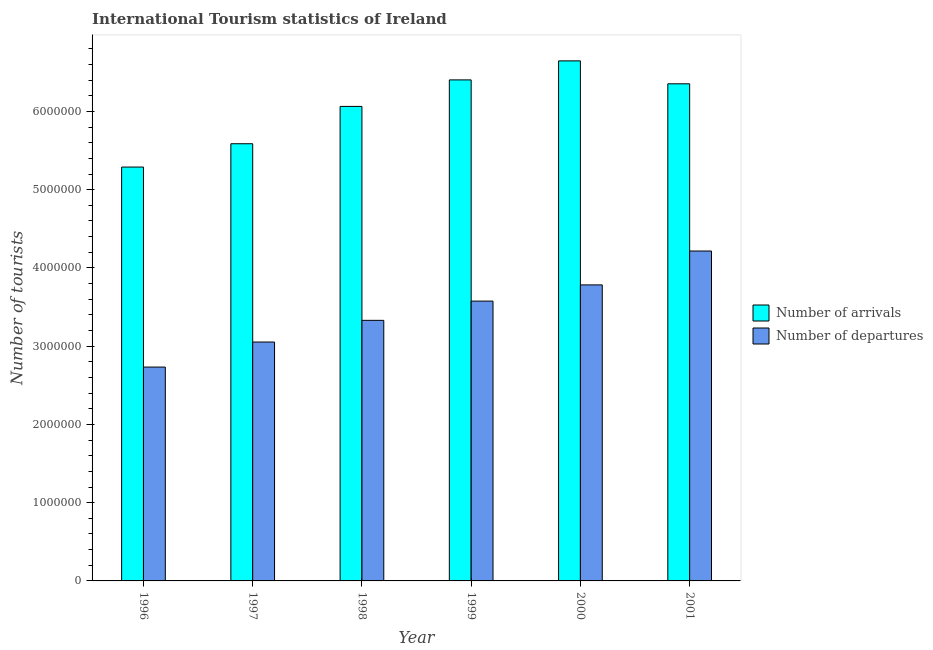How many different coloured bars are there?
Make the answer very short. 2. Are the number of bars per tick equal to the number of legend labels?
Provide a succinct answer. Yes. How many bars are there on the 1st tick from the right?
Provide a succinct answer. 2. What is the label of the 1st group of bars from the left?
Give a very brief answer. 1996. What is the number of tourist departures in 2001?
Your response must be concise. 4.22e+06. Across all years, what is the maximum number of tourist departures?
Provide a succinct answer. 4.22e+06. Across all years, what is the minimum number of tourist departures?
Offer a terse response. 2.73e+06. In which year was the number of tourist arrivals maximum?
Provide a succinct answer. 2000. What is the total number of tourist departures in the graph?
Offer a terse response. 2.07e+07. What is the difference between the number of tourist arrivals in 1997 and that in 2000?
Make the answer very short. -1.06e+06. What is the difference between the number of tourist departures in 1999 and the number of tourist arrivals in 1998?
Give a very brief answer. 2.46e+05. What is the average number of tourist departures per year?
Your answer should be very brief. 3.45e+06. In how many years, is the number of tourist departures greater than 5800000?
Give a very brief answer. 0. What is the ratio of the number of tourist departures in 1998 to that in 2001?
Provide a succinct answer. 0.79. Is the number of tourist arrivals in 2000 less than that in 2001?
Your answer should be very brief. No. What is the difference between the highest and the second highest number of tourist departures?
Give a very brief answer. 4.33e+05. What is the difference between the highest and the lowest number of tourist departures?
Provide a short and direct response. 1.48e+06. In how many years, is the number of tourist departures greater than the average number of tourist departures taken over all years?
Ensure brevity in your answer.  3. What does the 1st bar from the left in 1999 represents?
Keep it short and to the point. Number of arrivals. What does the 1st bar from the right in 1997 represents?
Provide a succinct answer. Number of departures. Are all the bars in the graph horizontal?
Ensure brevity in your answer.  No. Are the values on the major ticks of Y-axis written in scientific E-notation?
Keep it short and to the point. No. Does the graph contain grids?
Give a very brief answer. No. Where does the legend appear in the graph?
Your response must be concise. Center right. How many legend labels are there?
Offer a very short reply. 2. What is the title of the graph?
Your response must be concise. International Tourism statistics of Ireland. Does "Male population" appear as one of the legend labels in the graph?
Offer a very short reply. No. What is the label or title of the Y-axis?
Provide a short and direct response. Number of tourists. What is the Number of tourists in Number of arrivals in 1996?
Give a very brief answer. 5.29e+06. What is the Number of tourists in Number of departures in 1996?
Your response must be concise. 2.73e+06. What is the Number of tourists of Number of arrivals in 1997?
Provide a short and direct response. 5.59e+06. What is the Number of tourists in Number of departures in 1997?
Offer a terse response. 3.05e+06. What is the Number of tourists of Number of arrivals in 1998?
Your response must be concise. 6.06e+06. What is the Number of tourists of Number of departures in 1998?
Offer a very short reply. 3.33e+06. What is the Number of tourists of Number of arrivals in 1999?
Your answer should be very brief. 6.40e+06. What is the Number of tourists in Number of departures in 1999?
Offer a terse response. 3.58e+06. What is the Number of tourists of Number of arrivals in 2000?
Offer a terse response. 6.65e+06. What is the Number of tourists in Number of departures in 2000?
Give a very brief answer. 3.78e+06. What is the Number of tourists in Number of arrivals in 2001?
Make the answer very short. 6.35e+06. What is the Number of tourists in Number of departures in 2001?
Provide a succinct answer. 4.22e+06. Across all years, what is the maximum Number of tourists of Number of arrivals?
Your answer should be very brief. 6.65e+06. Across all years, what is the maximum Number of tourists in Number of departures?
Your response must be concise. 4.22e+06. Across all years, what is the minimum Number of tourists of Number of arrivals?
Your response must be concise. 5.29e+06. Across all years, what is the minimum Number of tourists in Number of departures?
Provide a succinct answer. 2.73e+06. What is the total Number of tourists in Number of arrivals in the graph?
Keep it short and to the point. 3.63e+07. What is the total Number of tourists in Number of departures in the graph?
Give a very brief answer. 2.07e+07. What is the difference between the Number of tourists in Number of arrivals in 1996 and that in 1997?
Your answer should be compact. -2.98e+05. What is the difference between the Number of tourists in Number of departures in 1996 and that in 1997?
Provide a short and direct response. -3.20e+05. What is the difference between the Number of tourists in Number of arrivals in 1996 and that in 1998?
Keep it short and to the point. -7.75e+05. What is the difference between the Number of tourists in Number of departures in 1996 and that in 1998?
Your answer should be very brief. -5.97e+05. What is the difference between the Number of tourists of Number of arrivals in 1996 and that in 1999?
Offer a very short reply. -1.11e+06. What is the difference between the Number of tourists in Number of departures in 1996 and that in 1999?
Give a very brief answer. -8.43e+05. What is the difference between the Number of tourists of Number of arrivals in 1996 and that in 2000?
Your response must be concise. -1.36e+06. What is the difference between the Number of tourists of Number of departures in 1996 and that in 2000?
Offer a terse response. -1.05e+06. What is the difference between the Number of tourists of Number of arrivals in 1996 and that in 2001?
Make the answer very short. -1.06e+06. What is the difference between the Number of tourists of Number of departures in 1996 and that in 2001?
Provide a short and direct response. -1.48e+06. What is the difference between the Number of tourists in Number of arrivals in 1997 and that in 1998?
Give a very brief answer. -4.77e+05. What is the difference between the Number of tourists in Number of departures in 1997 and that in 1998?
Give a very brief answer. -2.77e+05. What is the difference between the Number of tourists of Number of arrivals in 1997 and that in 1999?
Make the answer very short. -8.16e+05. What is the difference between the Number of tourists in Number of departures in 1997 and that in 1999?
Your response must be concise. -5.23e+05. What is the difference between the Number of tourists of Number of arrivals in 1997 and that in 2000?
Ensure brevity in your answer.  -1.06e+06. What is the difference between the Number of tourists in Number of departures in 1997 and that in 2000?
Provide a succinct answer. -7.30e+05. What is the difference between the Number of tourists in Number of arrivals in 1997 and that in 2001?
Offer a terse response. -7.66e+05. What is the difference between the Number of tourists of Number of departures in 1997 and that in 2001?
Your answer should be compact. -1.16e+06. What is the difference between the Number of tourists in Number of arrivals in 1998 and that in 1999?
Your answer should be very brief. -3.39e+05. What is the difference between the Number of tourists in Number of departures in 1998 and that in 1999?
Provide a succinct answer. -2.46e+05. What is the difference between the Number of tourists of Number of arrivals in 1998 and that in 2000?
Provide a succinct answer. -5.82e+05. What is the difference between the Number of tourists of Number of departures in 1998 and that in 2000?
Offer a terse response. -4.53e+05. What is the difference between the Number of tourists of Number of arrivals in 1998 and that in 2001?
Offer a terse response. -2.89e+05. What is the difference between the Number of tourists in Number of departures in 1998 and that in 2001?
Make the answer very short. -8.86e+05. What is the difference between the Number of tourists of Number of arrivals in 1999 and that in 2000?
Provide a short and direct response. -2.43e+05. What is the difference between the Number of tourists in Number of departures in 1999 and that in 2000?
Offer a very short reply. -2.07e+05. What is the difference between the Number of tourists in Number of arrivals in 1999 and that in 2001?
Provide a succinct answer. 5.00e+04. What is the difference between the Number of tourists in Number of departures in 1999 and that in 2001?
Ensure brevity in your answer.  -6.40e+05. What is the difference between the Number of tourists in Number of arrivals in 2000 and that in 2001?
Your answer should be very brief. 2.93e+05. What is the difference between the Number of tourists in Number of departures in 2000 and that in 2001?
Give a very brief answer. -4.33e+05. What is the difference between the Number of tourists of Number of arrivals in 1996 and the Number of tourists of Number of departures in 1997?
Your answer should be compact. 2.24e+06. What is the difference between the Number of tourists in Number of arrivals in 1996 and the Number of tourists in Number of departures in 1998?
Your answer should be compact. 1.96e+06. What is the difference between the Number of tourists of Number of arrivals in 1996 and the Number of tourists of Number of departures in 1999?
Your answer should be very brief. 1.71e+06. What is the difference between the Number of tourists in Number of arrivals in 1996 and the Number of tourists in Number of departures in 2000?
Ensure brevity in your answer.  1.51e+06. What is the difference between the Number of tourists of Number of arrivals in 1996 and the Number of tourists of Number of departures in 2001?
Ensure brevity in your answer.  1.07e+06. What is the difference between the Number of tourists in Number of arrivals in 1997 and the Number of tourists in Number of departures in 1998?
Offer a very short reply. 2.26e+06. What is the difference between the Number of tourists of Number of arrivals in 1997 and the Number of tourists of Number of departures in 1999?
Provide a short and direct response. 2.01e+06. What is the difference between the Number of tourists of Number of arrivals in 1997 and the Number of tourists of Number of departures in 2000?
Provide a succinct answer. 1.80e+06. What is the difference between the Number of tourists in Number of arrivals in 1997 and the Number of tourists in Number of departures in 2001?
Provide a short and direct response. 1.37e+06. What is the difference between the Number of tourists of Number of arrivals in 1998 and the Number of tourists of Number of departures in 1999?
Ensure brevity in your answer.  2.49e+06. What is the difference between the Number of tourists in Number of arrivals in 1998 and the Number of tourists in Number of departures in 2000?
Offer a very short reply. 2.28e+06. What is the difference between the Number of tourists in Number of arrivals in 1998 and the Number of tourists in Number of departures in 2001?
Your response must be concise. 1.85e+06. What is the difference between the Number of tourists in Number of arrivals in 1999 and the Number of tourists in Number of departures in 2000?
Give a very brief answer. 2.62e+06. What is the difference between the Number of tourists in Number of arrivals in 1999 and the Number of tourists in Number of departures in 2001?
Give a very brief answer. 2.19e+06. What is the difference between the Number of tourists of Number of arrivals in 2000 and the Number of tourists of Number of departures in 2001?
Give a very brief answer. 2.43e+06. What is the average Number of tourists of Number of arrivals per year?
Provide a short and direct response. 6.06e+06. What is the average Number of tourists of Number of departures per year?
Your answer should be very brief. 3.45e+06. In the year 1996, what is the difference between the Number of tourists in Number of arrivals and Number of tourists in Number of departures?
Your answer should be compact. 2.56e+06. In the year 1997, what is the difference between the Number of tourists in Number of arrivals and Number of tourists in Number of departures?
Provide a succinct answer. 2.53e+06. In the year 1998, what is the difference between the Number of tourists of Number of arrivals and Number of tourists of Number of departures?
Keep it short and to the point. 2.73e+06. In the year 1999, what is the difference between the Number of tourists of Number of arrivals and Number of tourists of Number of departures?
Ensure brevity in your answer.  2.83e+06. In the year 2000, what is the difference between the Number of tourists in Number of arrivals and Number of tourists in Number of departures?
Give a very brief answer. 2.86e+06. In the year 2001, what is the difference between the Number of tourists in Number of arrivals and Number of tourists in Number of departures?
Provide a short and direct response. 2.14e+06. What is the ratio of the Number of tourists of Number of arrivals in 1996 to that in 1997?
Offer a very short reply. 0.95. What is the ratio of the Number of tourists in Number of departures in 1996 to that in 1997?
Offer a terse response. 0.9. What is the ratio of the Number of tourists in Number of arrivals in 1996 to that in 1998?
Offer a very short reply. 0.87. What is the ratio of the Number of tourists in Number of departures in 1996 to that in 1998?
Make the answer very short. 0.82. What is the ratio of the Number of tourists in Number of arrivals in 1996 to that in 1999?
Provide a short and direct response. 0.83. What is the ratio of the Number of tourists of Number of departures in 1996 to that in 1999?
Your answer should be compact. 0.76. What is the ratio of the Number of tourists of Number of arrivals in 1996 to that in 2000?
Keep it short and to the point. 0.8. What is the ratio of the Number of tourists in Number of departures in 1996 to that in 2000?
Give a very brief answer. 0.72. What is the ratio of the Number of tourists in Number of arrivals in 1996 to that in 2001?
Make the answer very short. 0.83. What is the ratio of the Number of tourists in Number of departures in 1996 to that in 2001?
Keep it short and to the point. 0.65. What is the ratio of the Number of tourists of Number of arrivals in 1997 to that in 1998?
Provide a succinct answer. 0.92. What is the ratio of the Number of tourists in Number of departures in 1997 to that in 1998?
Your response must be concise. 0.92. What is the ratio of the Number of tourists of Number of arrivals in 1997 to that in 1999?
Give a very brief answer. 0.87. What is the ratio of the Number of tourists of Number of departures in 1997 to that in 1999?
Your response must be concise. 0.85. What is the ratio of the Number of tourists of Number of arrivals in 1997 to that in 2000?
Keep it short and to the point. 0.84. What is the ratio of the Number of tourists of Number of departures in 1997 to that in 2000?
Offer a very short reply. 0.81. What is the ratio of the Number of tourists of Number of arrivals in 1997 to that in 2001?
Your answer should be very brief. 0.88. What is the ratio of the Number of tourists of Number of departures in 1997 to that in 2001?
Keep it short and to the point. 0.72. What is the ratio of the Number of tourists in Number of arrivals in 1998 to that in 1999?
Keep it short and to the point. 0.95. What is the ratio of the Number of tourists of Number of departures in 1998 to that in 1999?
Provide a succinct answer. 0.93. What is the ratio of the Number of tourists in Number of arrivals in 1998 to that in 2000?
Provide a short and direct response. 0.91. What is the ratio of the Number of tourists in Number of departures in 1998 to that in 2000?
Give a very brief answer. 0.88. What is the ratio of the Number of tourists in Number of arrivals in 1998 to that in 2001?
Make the answer very short. 0.95. What is the ratio of the Number of tourists in Number of departures in 1998 to that in 2001?
Give a very brief answer. 0.79. What is the ratio of the Number of tourists of Number of arrivals in 1999 to that in 2000?
Keep it short and to the point. 0.96. What is the ratio of the Number of tourists in Number of departures in 1999 to that in 2000?
Your answer should be compact. 0.95. What is the ratio of the Number of tourists in Number of arrivals in 1999 to that in 2001?
Offer a very short reply. 1.01. What is the ratio of the Number of tourists in Number of departures in 1999 to that in 2001?
Keep it short and to the point. 0.85. What is the ratio of the Number of tourists in Number of arrivals in 2000 to that in 2001?
Your answer should be very brief. 1.05. What is the ratio of the Number of tourists in Number of departures in 2000 to that in 2001?
Ensure brevity in your answer.  0.9. What is the difference between the highest and the second highest Number of tourists in Number of arrivals?
Provide a short and direct response. 2.43e+05. What is the difference between the highest and the second highest Number of tourists in Number of departures?
Offer a terse response. 4.33e+05. What is the difference between the highest and the lowest Number of tourists of Number of arrivals?
Your answer should be compact. 1.36e+06. What is the difference between the highest and the lowest Number of tourists in Number of departures?
Your answer should be very brief. 1.48e+06. 